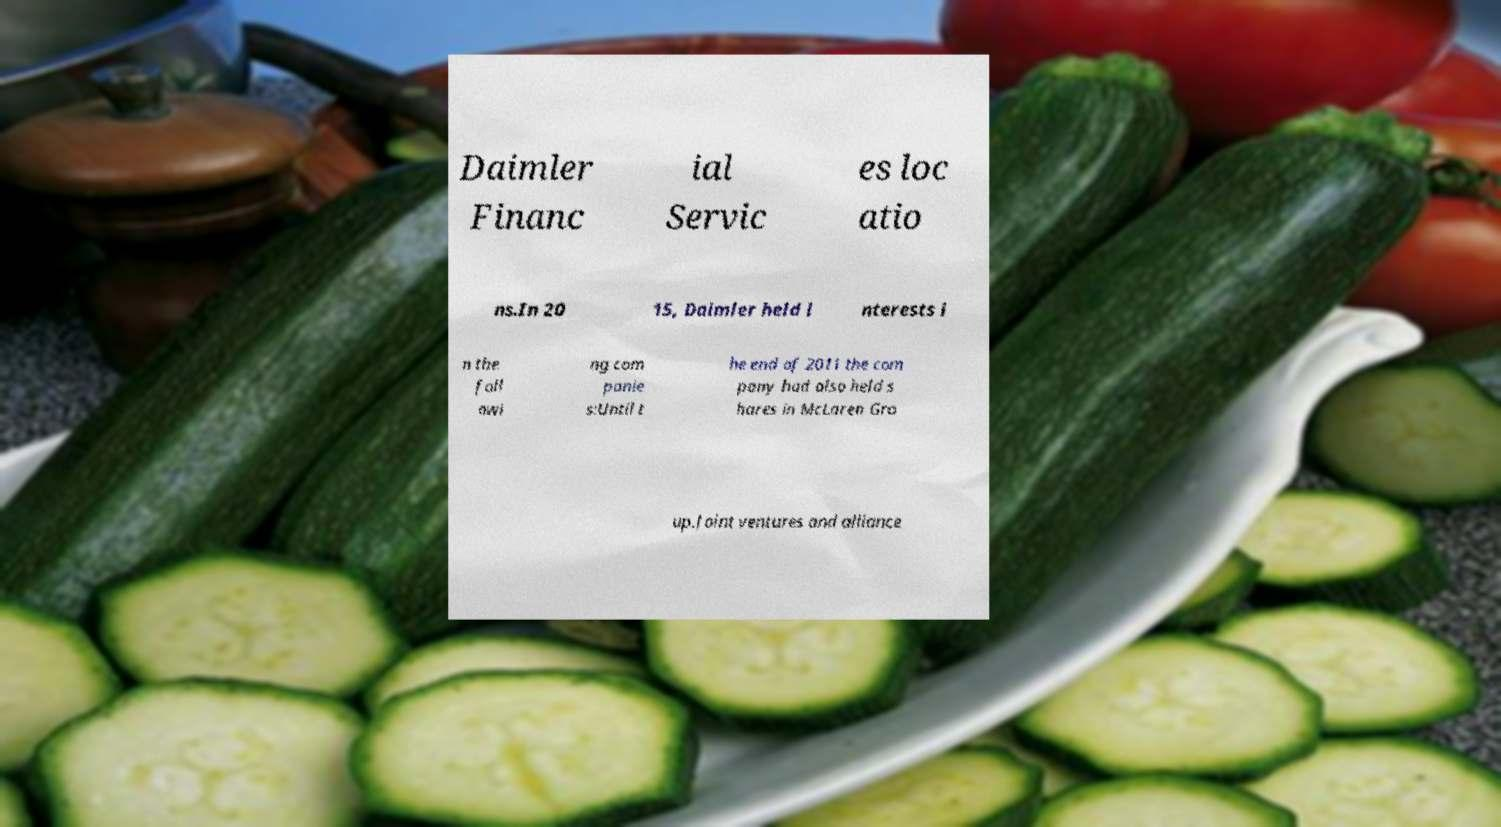Can you accurately transcribe the text from the provided image for me? Daimler Financ ial Servic es loc atio ns.In 20 15, Daimler held i nterests i n the foll owi ng com panie s:Until t he end of 2011 the com pany had also held s hares in McLaren Gro up.Joint ventures and alliance 